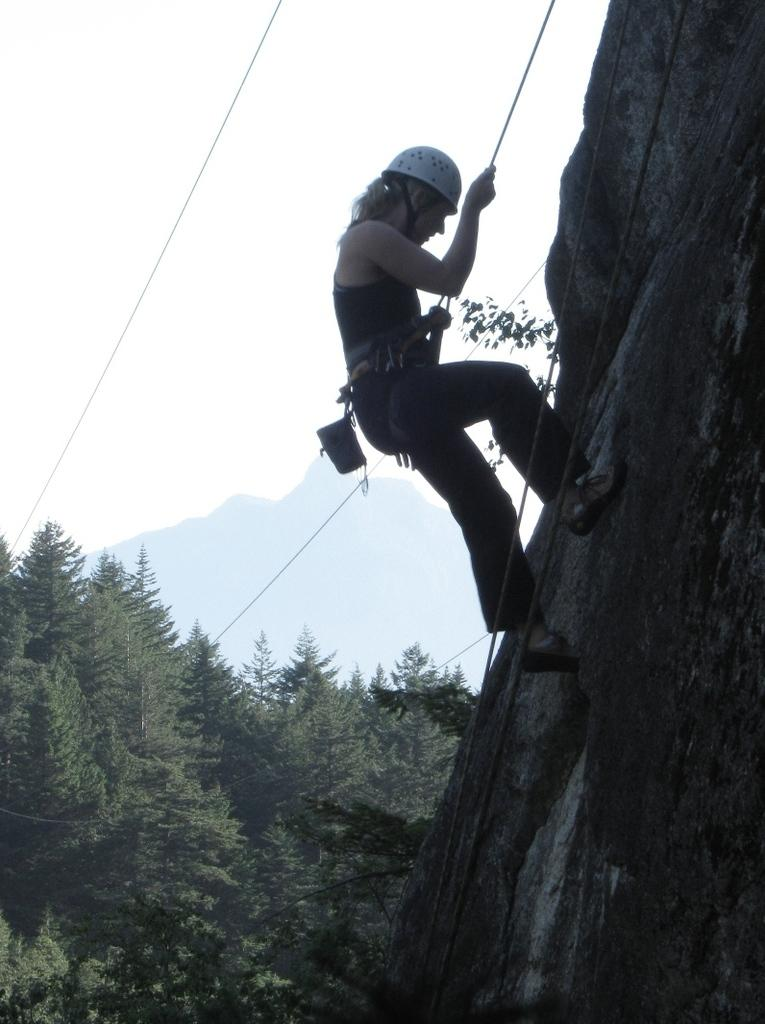Who is present in the image? There is a person in the image. What is the person holding in the image? The person is holding a rope in the image. What activity is the person engaged in? The person is climbing a mountain in the image. What type of vegetation can be seen in the image? There are trees visible in the image. What can be seen in the distance in the image? There is a hill in the background of the image, and the sky is visible as well. Where is the kitten located in the image? There is no kitten present in the image. What decision is the person making in the image? The image does not provide information about any decisions being made by the person. 